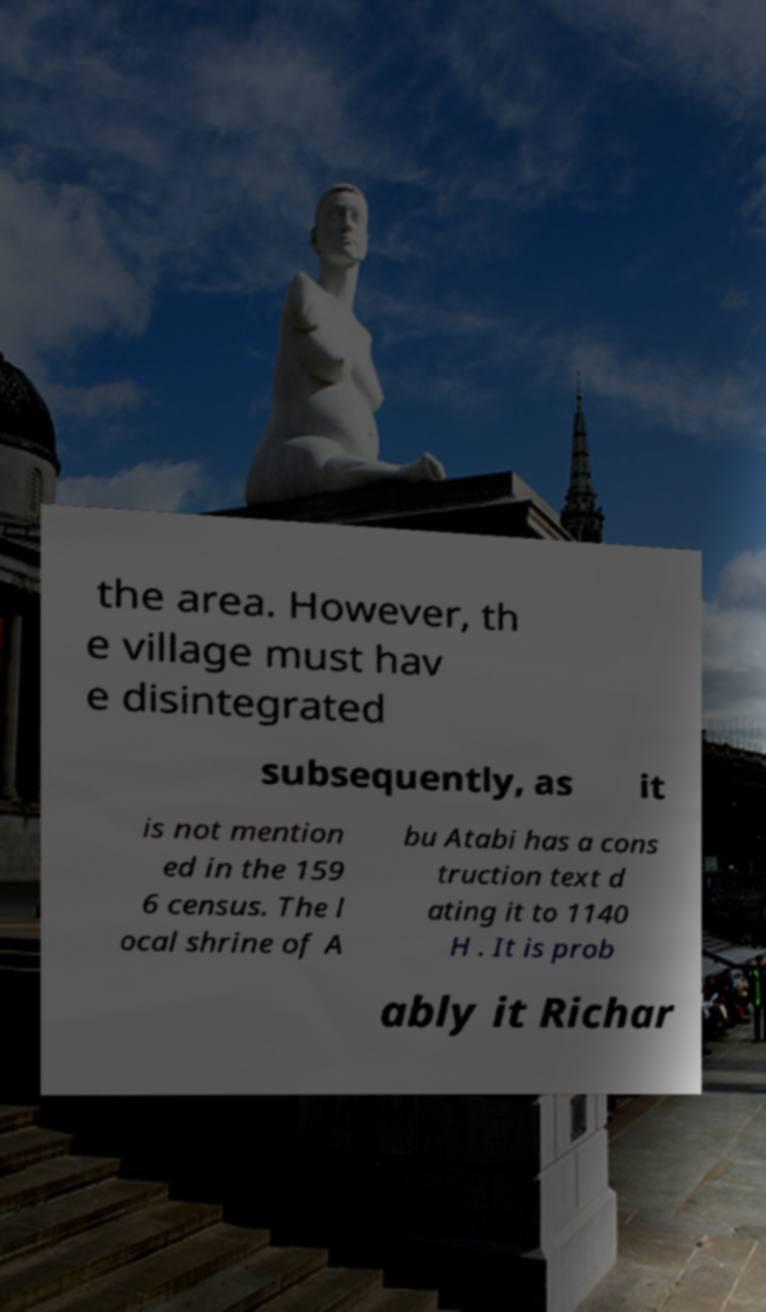Can you accurately transcribe the text from the provided image for me? the area. However, th e village must hav e disintegrated subsequently, as it is not mention ed in the 159 6 census. The l ocal shrine of A bu Atabi has a cons truction text d ating it to 1140 H . It is prob ably it Richar 